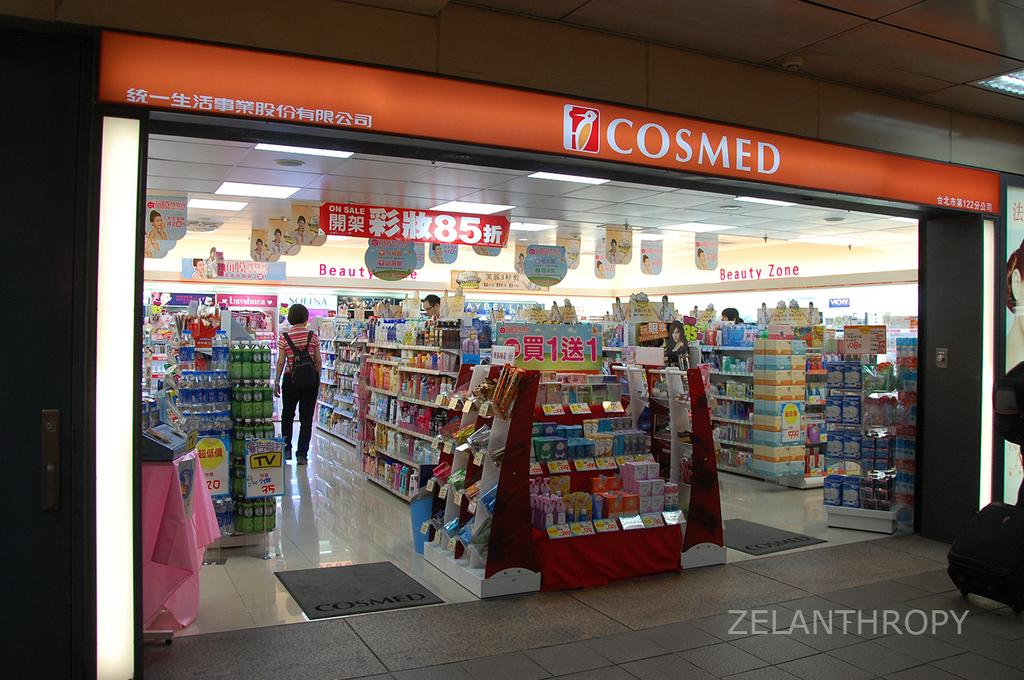<image>
Relay a brief, clear account of the picture shown. The Cosmed store has a Beauty Zone in it. 